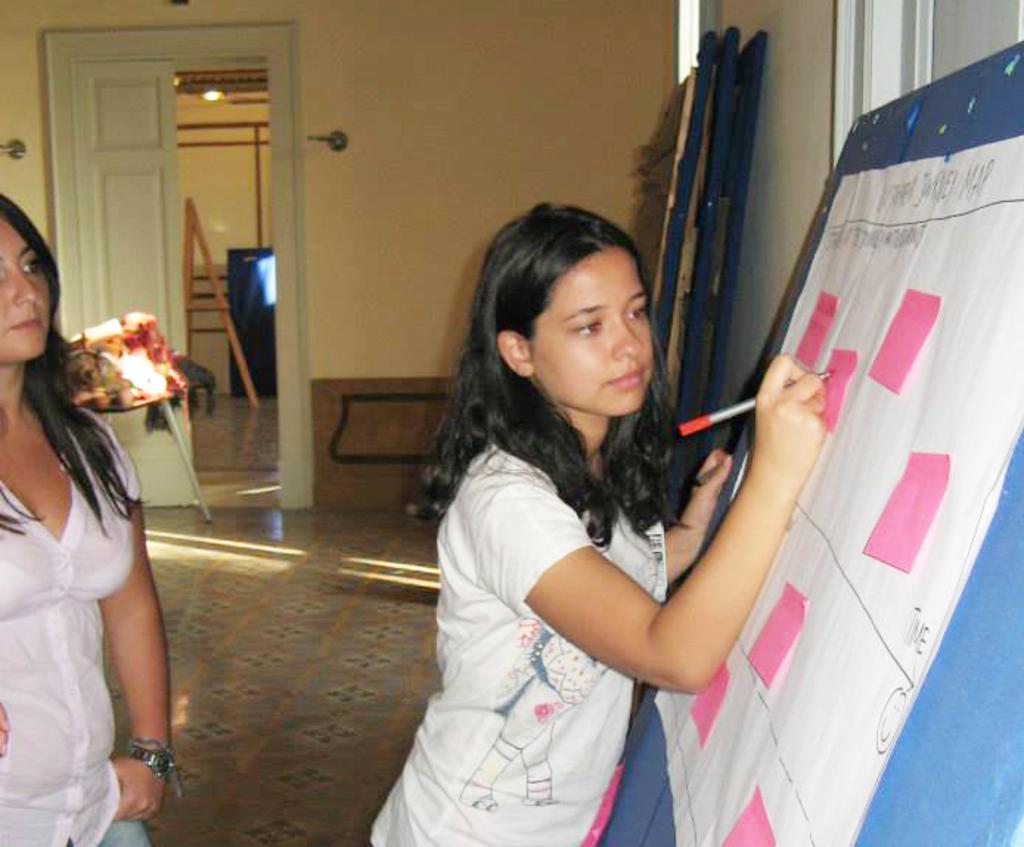Describe this image in one or two sentences. In this image I can see two women are standing among them this woman is holding a pen in the hand. Here I can see a board on which a chart is attached to it. On the chart I can see diagrams and something written on it. In the background I can see a wall, a door and other objects on the floor. 